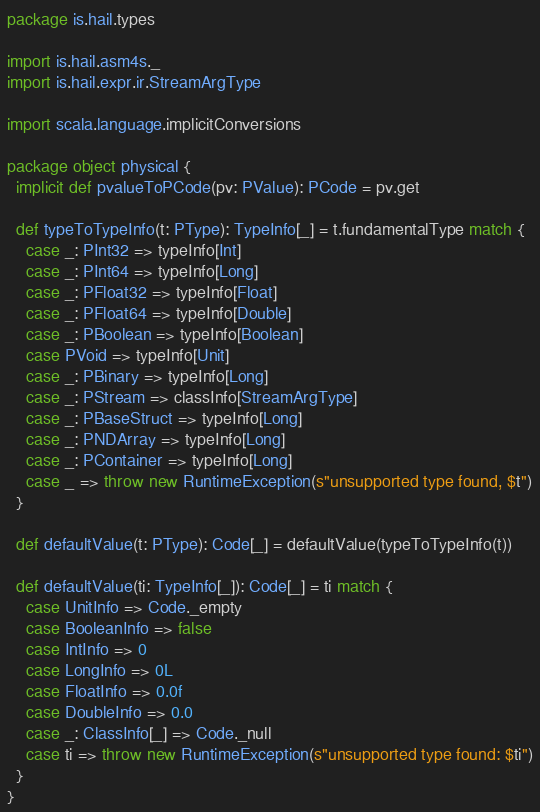Convert code to text. <code><loc_0><loc_0><loc_500><loc_500><_Scala_>package is.hail.types

import is.hail.asm4s._
import is.hail.expr.ir.StreamArgType

import scala.language.implicitConversions

package object physical {
  implicit def pvalueToPCode(pv: PValue): PCode = pv.get

  def typeToTypeInfo(t: PType): TypeInfo[_] = t.fundamentalType match {
    case _: PInt32 => typeInfo[Int]
    case _: PInt64 => typeInfo[Long]
    case _: PFloat32 => typeInfo[Float]
    case _: PFloat64 => typeInfo[Double]
    case _: PBoolean => typeInfo[Boolean]
    case PVoid => typeInfo[Unit]
    case _: PBinary => typeInfo[Long]
    case _: PStream => classInfo[StreamArgType]
    case _: PBaseStruct => typeInfo[Long]
    case _: PNDArray => typeInfo[Long]
    case _: PContainer => typeInfo[Long]
    case _ => throw new RuntimeException(s"unsupported type found, $t")
  }

  def defaultValue(t: PType): Code[_] = defaultValue(typeToTypeInfo(t))

  def defaultValue(ti: TypeInfo[_]): Code[_] = ti match {
    case UnitInfo => Code._empty
    case BooleanInfo => false
    case IntInfo => 0
    case LongInfo => 0L
    case FloatInfo => 0.0f
    case DoubleInfo => 0.0
    case _: ClassInfo[_] => Code._null
    case ti => throw new RuntimeException(s"unsupported type found: $ti")
  }
}
</code> 